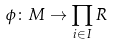Convert formula to latex. <formula><loc_0><loc_0><loc_500><loc_500>\phi \colon M \rightarrow \prod _ { i \in I } R</formula> 